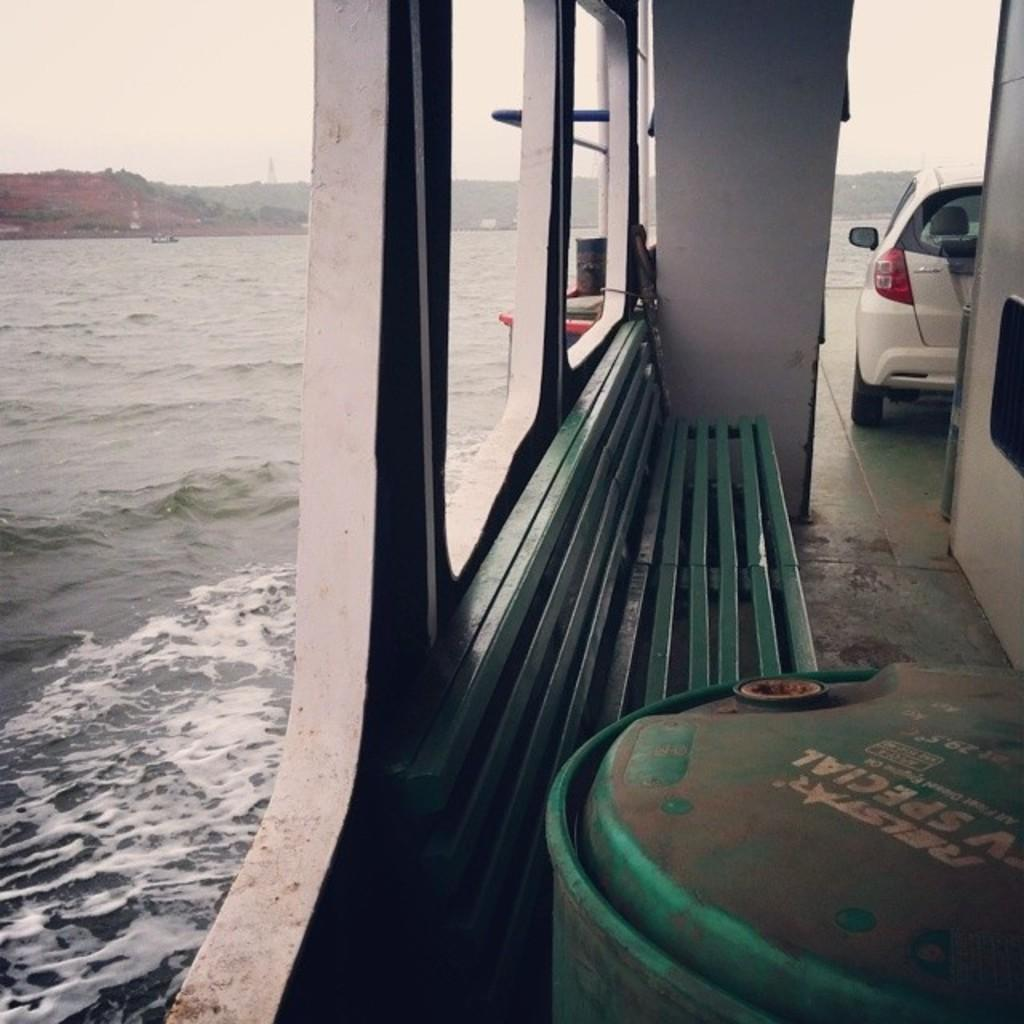What is the main subject of the image? The main subject of the image is a boat. Where is the boat located? The boat is on the water surface. What is inside the boat? There is a car in the boat. What can be seen in the background of the image? There are mountains visible in the background of the image. What type of furniture is present in the image? There is a chair in the image. What texture can be seen on the eyes of the tramp in the image? There is no tramp or eyes present in the image; it features a boat with a car inside and mountains in the background. 